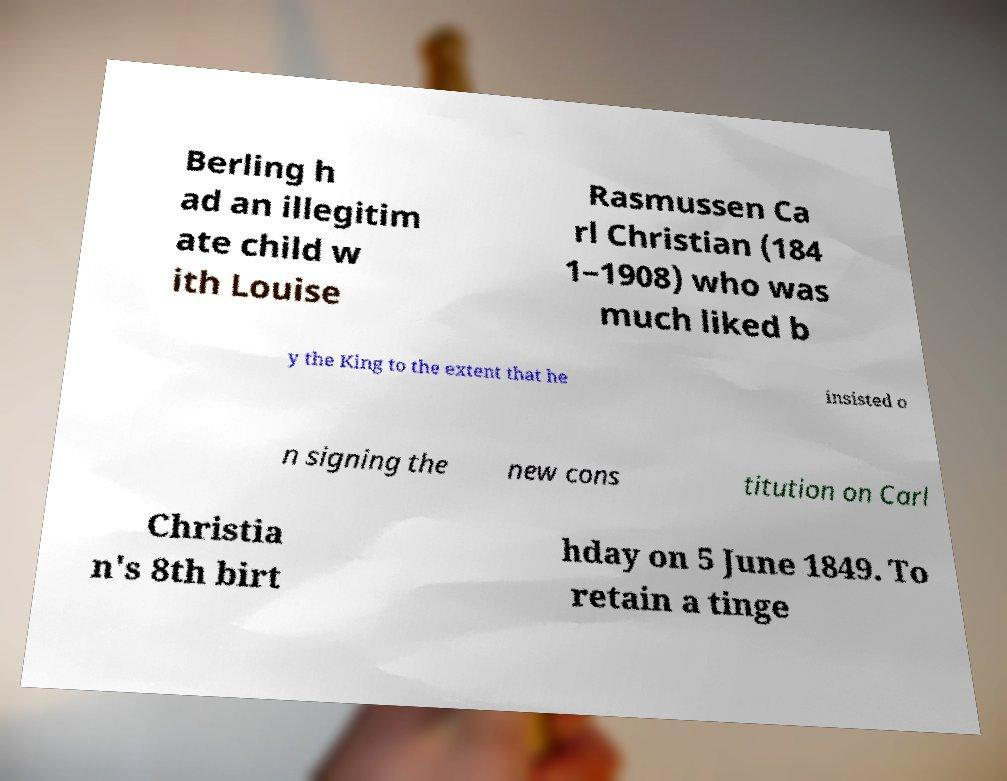What messages or text are displayed in this image? I need them in a readable, typed format. Berling h ad an illegitim ate child w ith Louise Rasmussen Ca rl Christian (184 1–1908) who was much liked b y the King to the extent that he insisted o n signing the new cons titution on Carl Christia n's 8th birt hday on 5 June 1849. To retain a tinge 